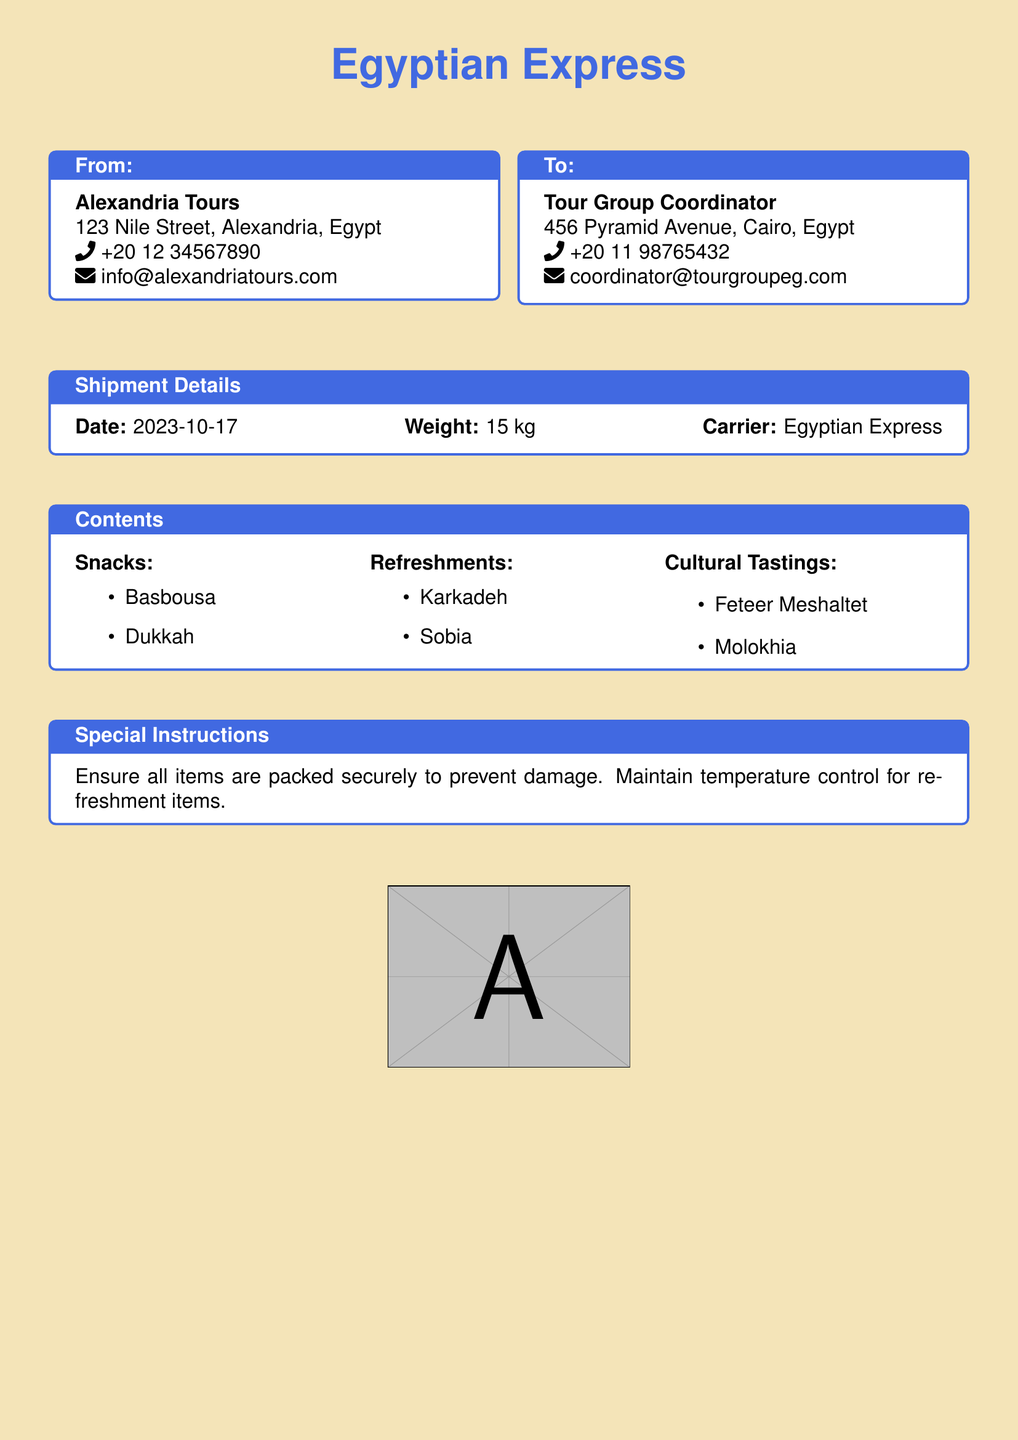What is the date of the shipment? The date of the shipment is clearly mentioned in the document under the shipment details section.
Answer: 2023-10-17 What is the weight of the shipment? The document specifies the weight of the shipment in the shipment details section.
Answer: 15 kg Who is the sender of the shipment? The sender's information is listed in the 'From:' box of the document.
Answer: Alexandria Tours What are the refreshments included in the shipment? The refreshments are listed in the 'Contents' section of the document under refreshments.
Answer: Karkadeh, Sobia What special instructions are provided for the shipment? The special instructions are detailed in their own section, outlining precautions for handling the items.
Answer: Ensure all items are packed securely to prevent damage How many different snacks are listed in the document? The snacks are enumerated in the 'Contents' section, allowing us to count them easily.
Answer: 2 What carrier is being used for this shipment? The carrier's name is stated in the shipment details section of the document.
Answer: Egyptian Express What is the email address of the sender? The sender's email is included in the 'From:' box of the document.
Answer: info@alexandriatours.com 